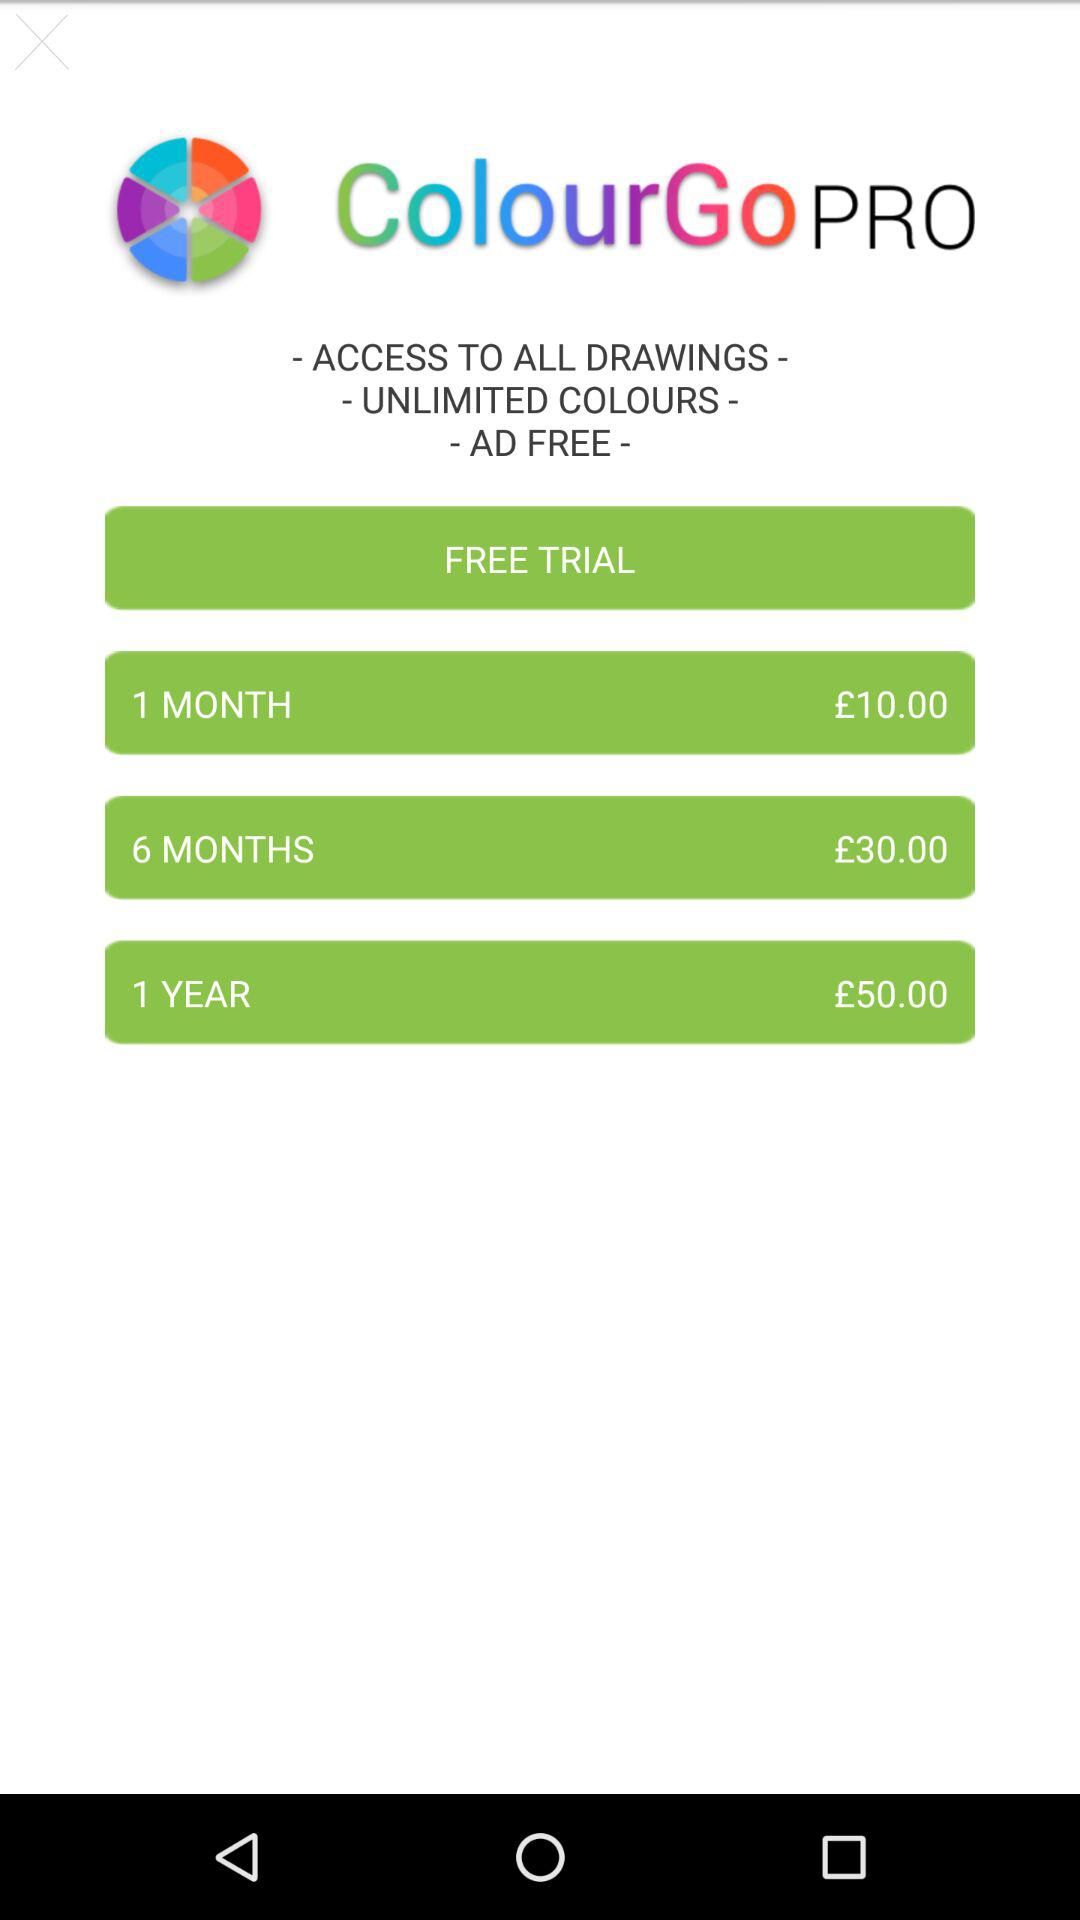What features are there in the pro version? The features are "ACCESS TO ALL DRAWINGS", "UNLIMITED COLOURS" and "AD FREE". 